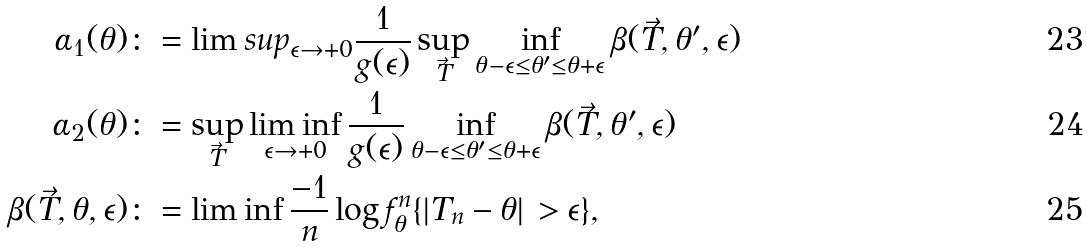<formula> <loc_0><loc_0><loc_500><loc_500>\alpha _ { 1 } ( \theta ) & \colon = \lim s u p _ { \epsilon \to + 0 } \frac { 1 } { g ( \epsilon ) } \sup _ { \vec { T } } \inf _ { \theta - \epsilon \leq \theta ^ { \prime } \leq \theta + \epsilon } \beta ( \vec { T } , \theta ^ { \prime } , \epsilon ) \\ \alpha _ { 2 } ( \theta ) & \colon = \sup _ { \vec { T } } \liminf _ { \epsilon \to + 0 } \frac { 1 } { g ( \epsilon ) } \inf _ { \theta - \epsilon \leq \theta ^ { \prime } \leq \theta + \epsilon } \beta ( \vec { T } , \theta ^ { \prime } , \epsilon ) \\ \beta ( \vec { T } , \theta , \epsilon ) & \colon = \liminf \frac { - 1 } { n } \log f ^ { n } _ { \theta } \{ | T _ { n } - \theta | \, > \epsilon \} ,</formula> 